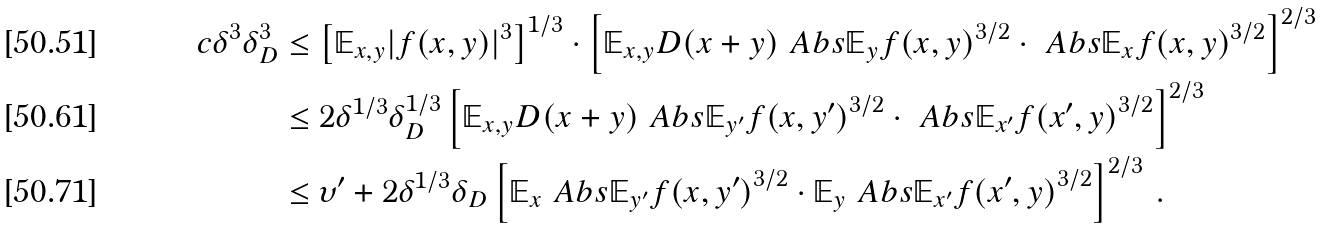<formula> <loc_0><loc_0><loc_500><loc_500>c \delta ^ { 3 } \delta _ { D } ^ { 3 } & \leq \left [ \mathbb { E } _ { x , y } | f ( x , y ) | ^ { 3 } \right ] ^ { 1 / 3 } \cdot \left [ \mathbb { E } _ { x , y } D ( x + y ) \ A b s { \mathbb { E } _ { y } f ( x , y ) } ^ { 3 / 2 } \cdot \ A b s { \mathbb { E } _ { x } f ( x , y ) } ^ { 3 / 2 } \right ] ^ { 2 / 3 } \\ & \leq 2 \delta ^ { 1 / 3 } \delta _ { D } ^ { 1 / 3 } \left [ \mathbb { E } _ { x , y } D ( x + y ) \ A b s { \mathbb { E } _ { y ^ { \prime } } f ( x , y ^ { \prime } ) } ^ { 3 / 2 } \cdot \ A b s { \mathbb { E } _ { x ^ { \prime } } f ( x ^ { \prime } , y ) } ^ { 3 / 2 } \right ] ^ { 2 / 3 } \\ & \leq \upsilon ^ { \prime } + 2 \delta ^ { 1 / 3 } \delta _ { D } \left [ \mathbb { E } _ { x } \ A b s { \mathbb { E } _ { y ^ { \prime } } f ( x , y ^ { \prime } ) } ^ { 3 / 2 } \cdot \mathbb { E } _ { y } \ A b s { \mathbb { E } _ { x ^ { \prime } } f ( x ^ { \prime } , y ) } ^ { 3 / 2 } \right ] ^ { 2 / 3 } \, .</formula> 